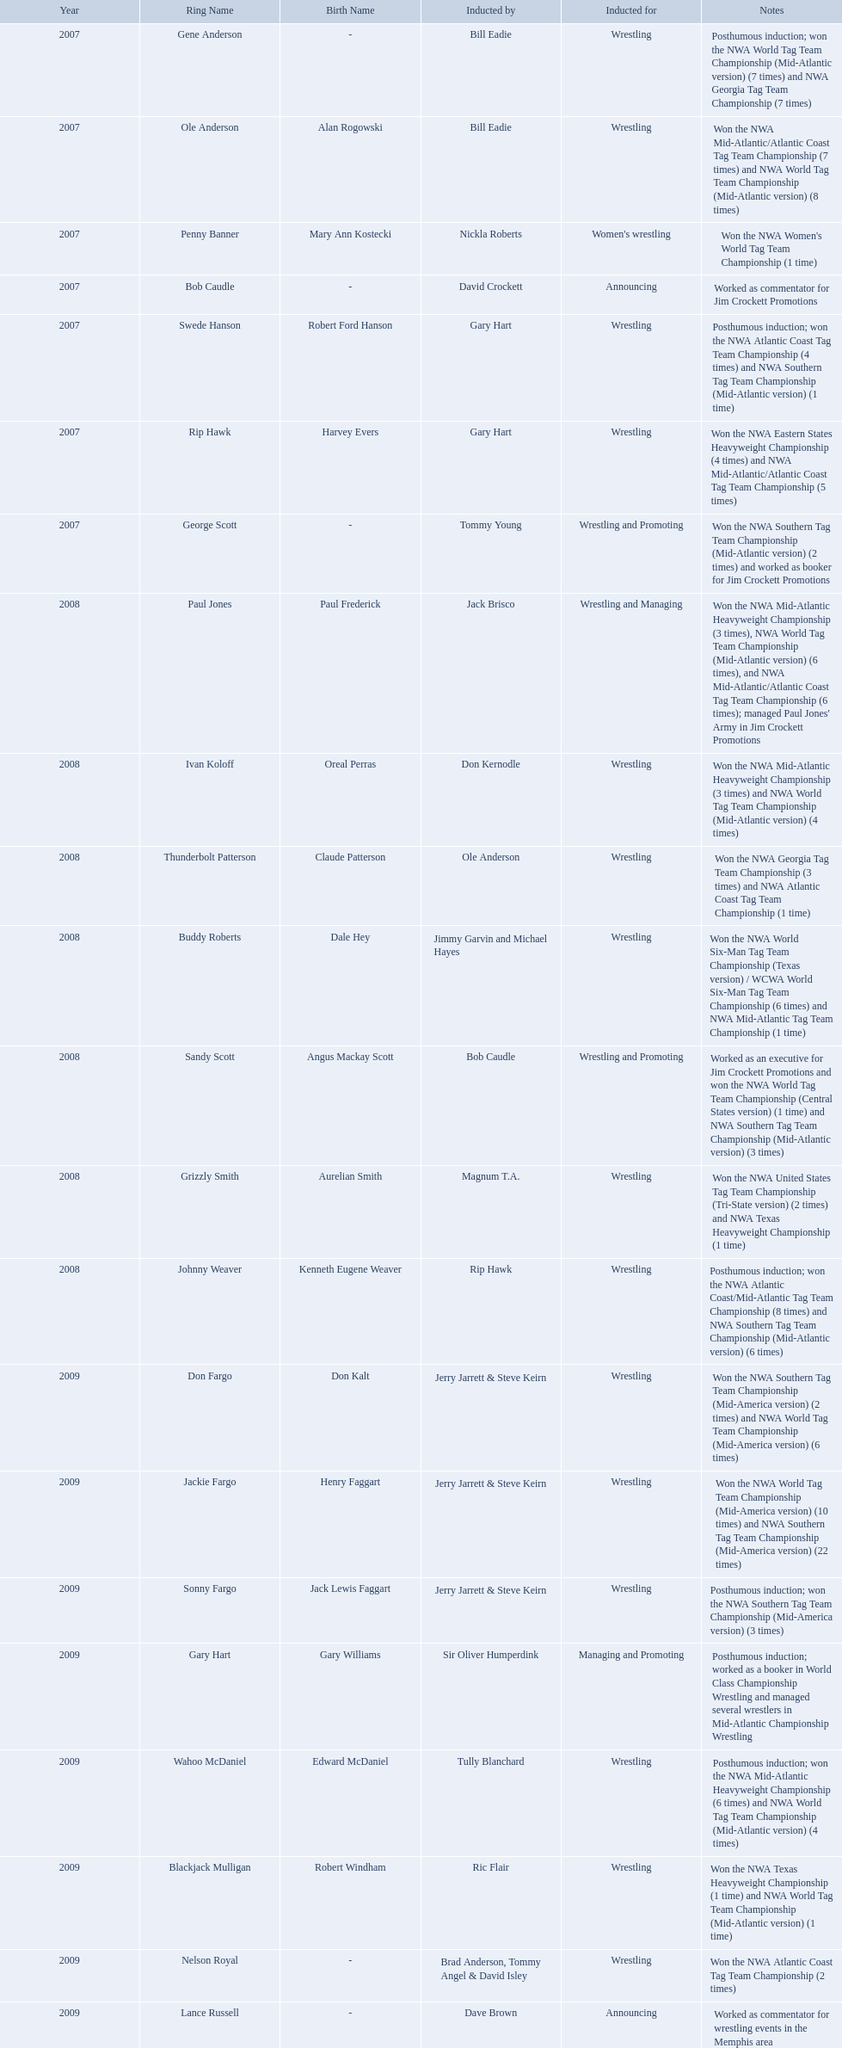Who was the announcer inducted into the hall of heroes in 2007? Bob Caudle. Who was the next announcer to be inducted? Lance Russell. 